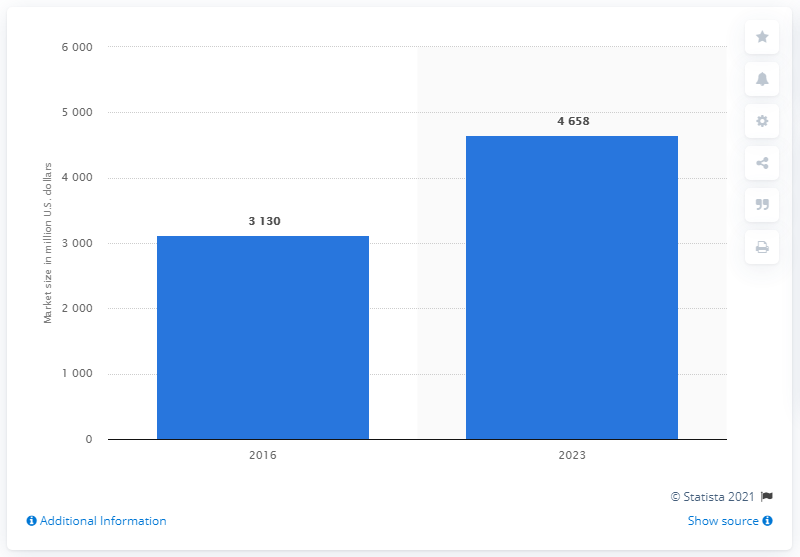What does the increase from 2016 to 2023 signify? The increase from 3.130 trillion U.S. dollars in 2016 to 4.658 trillion U.S. dollars in 2023 suggests significant growth in the market over this period, indicating a potentially healthy and expanding industry or stronger demand for its products or services. 